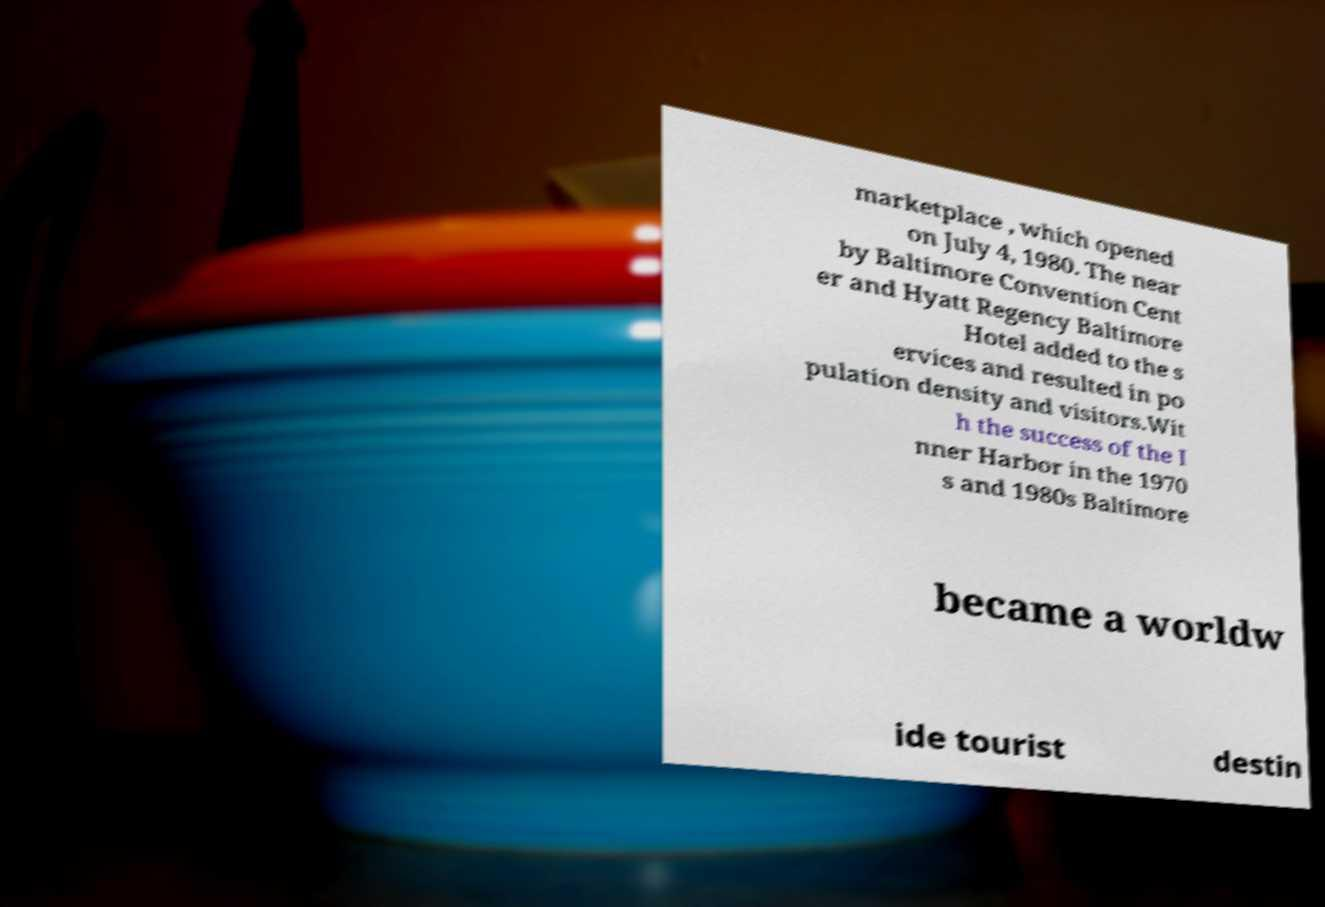I need the written content from this picture converted into text. Can you do that? marketplace , which opened on July 4, 1980. The near by Baltimore Convention Cent er and Hyatt Regency Baltimore Hotel added to the s ervices and resulted in po pulation density and visitors.Wit h the success of the I nner Harbor in the 1970 s and 1980s Baltimore became a worldw ide tourist destin 